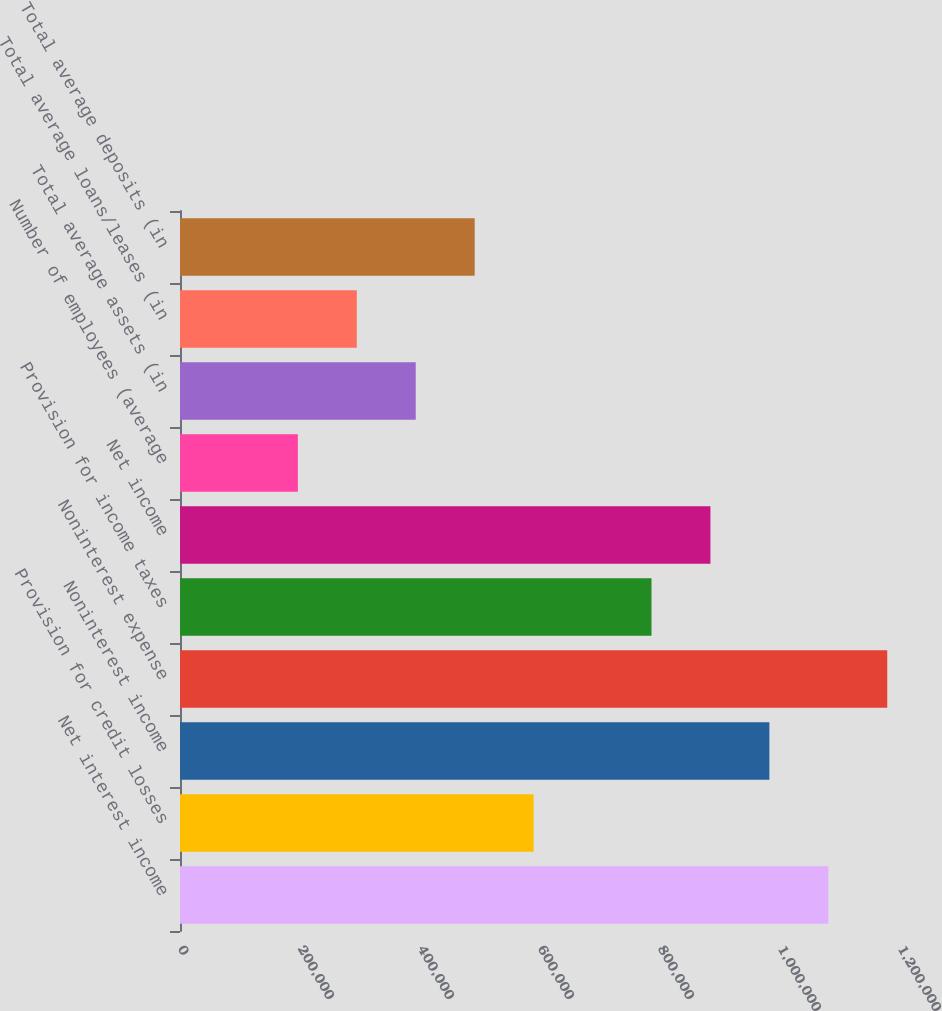Convert chart to OTSL. <chart><loc_0><loc_0><loc_500><loc_500><bar_chart><fcel>Net interest income<fcel>Provision for credit losses<fcel>Noninterest income<fcel>Noninterest expense<fcel>Provision for income taxes<fcel>Net income<fcel>Number of employees (average<fcel>Total average assets (in<fcel>Total average loans/leases (in<fcel>Total average deposits (in<nl><fcel>1.08052e+06<fcel>589373<fcel>982288<fcel>1.17875e+06<fcel>785831<fcel>884059<fcel>196458<fcel>392916<fcel>294687<fcel>491144<nl></chart> 